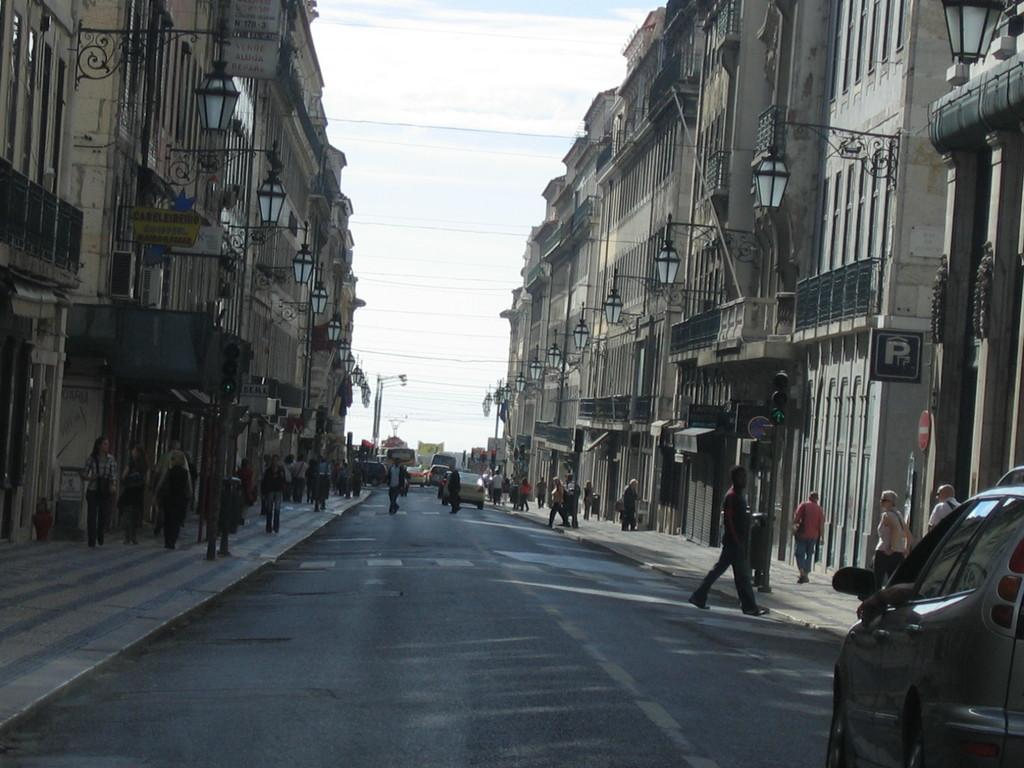What are the people in the image doing? The people in the image are walking. On what surfaces are the people walking? The people are walking on roads and pavements. What else can be seen in the image besides people walking? Cars are present in the image, and they are riding on the roads. What surrounds the roads in the image? There are buildings on either side of the roads. Can you tell me how many cannons are placed on the buildings in the image? There are no cannons present on the buildings in the image. What ideas are being discussed by the people walking in the image? The image does not provide any information about the ideas being discussed by the people walking. 